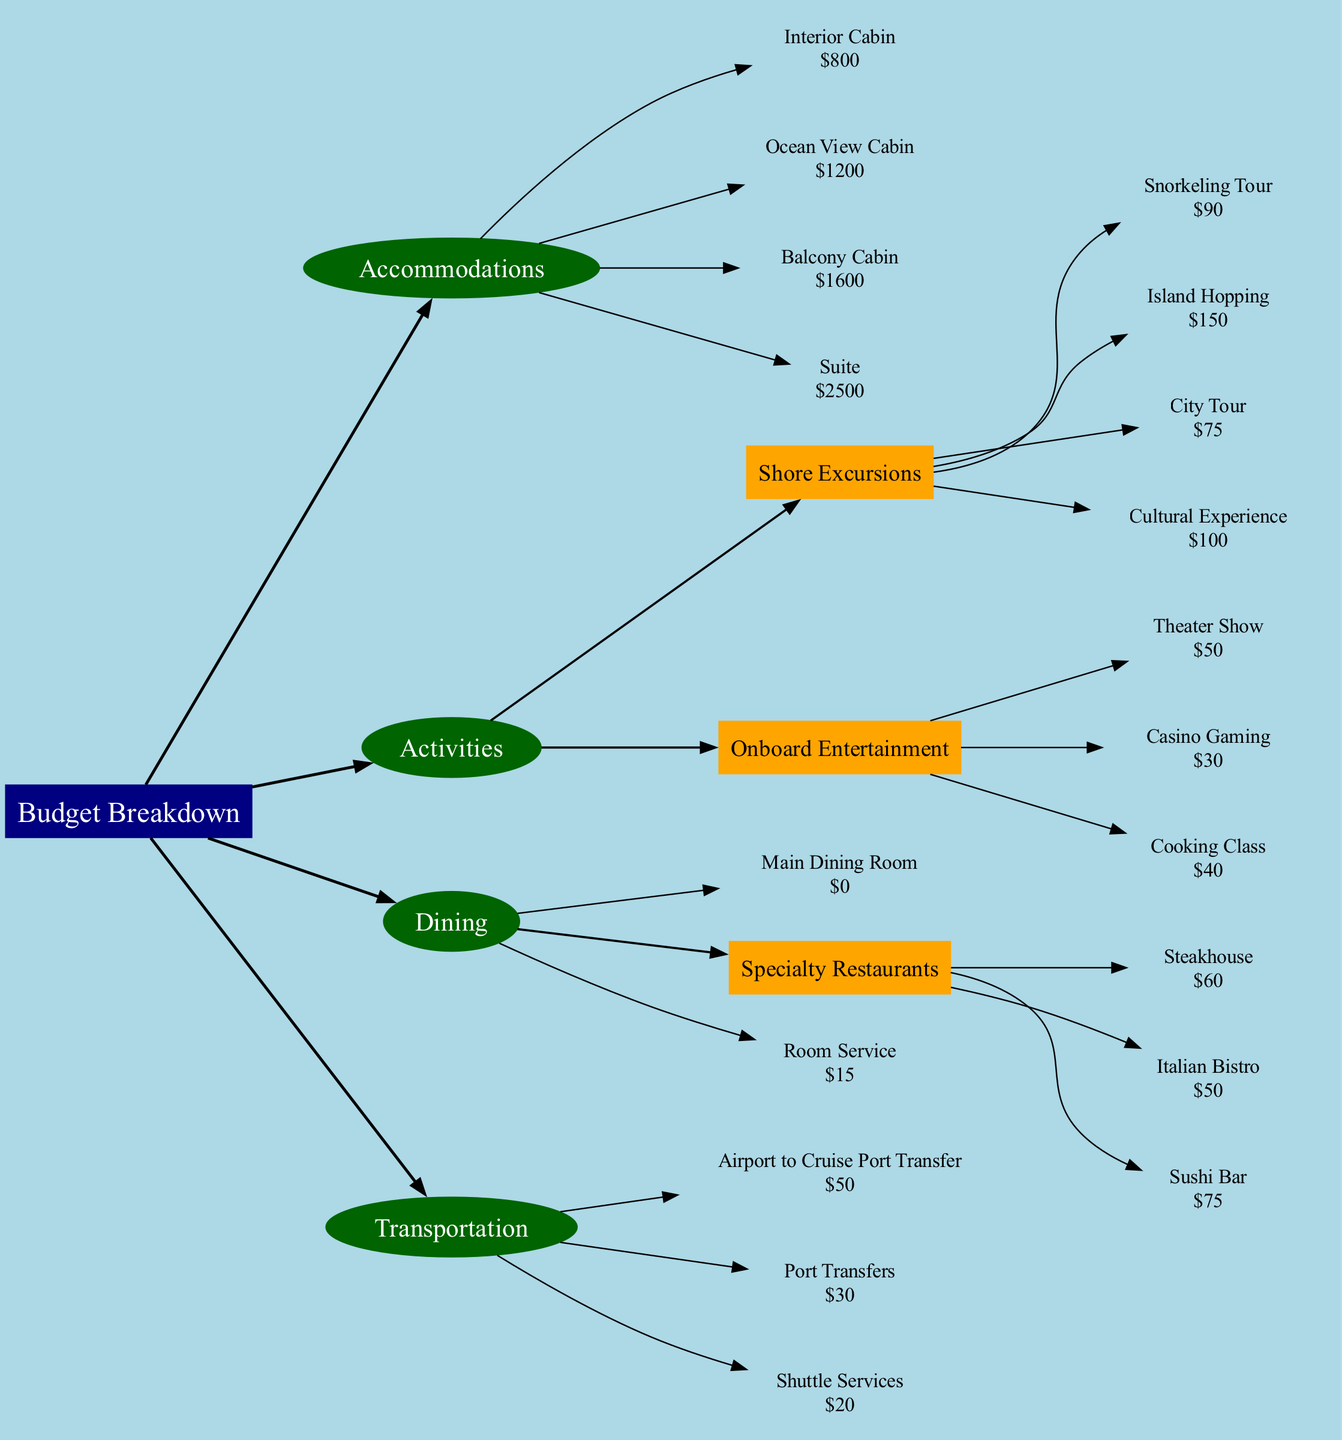What is the cost of a Balcony Cabin? The diagram presents the information under the Accommodations category. Specifically, the Balcony Cabin is listed as costing $1600.
Answer: $1600 How much does a Snorkeling Tour cost? The Snorkeling Tour is found in the Activities section, specifically within Shore Excursions, and it is priced at $90.
Answer: $90 What is the total cost of dining at the Specialty Restaurants? There are three Specialty Restaurants: Steakhouse costing $60, Italian Bistro costing $50, and Sushi Bar costing $75. The total is calculated as 60 + 50 + 75 = $185.
Answer: $185 Which activity has the highest cost? The activities are categorized under the Activities section. The highest cost belongs to Island Hopping at $150, which is greater than any other listed activity.
Answer: Island Hopping What is the total number of nodes in the diagram? The nodes include the main node (Budget Breakdown), four main categories (Accommodations, Activities, Dining, Transportation), their respective subcategories, and individual activities or dining options. In total, there are 15 nodes counted in the diagram.
Answer: 15 How many activities are listed under Onboard Entertainment? Under the Activities section, there are three distinct activities listed within Onboard Entertainment: Theater Show, Casino Gaming, and Cooking Class. This makes the total count of activities in this subcategory equal to 3.
Answer: 3 What is the total cost of transportation? The Transportation section lists three items: Airport to Cruise Port Transfer for $50, Port Transfers for $30, and Shuttle Services for $20. The total is calculated as 50 + 30 + 20 = $100.
Answer: $100 Which type of cabin costs the least? Under Accommodations, the different cabin types are Interior Cabin ($800), Ocean View Cabin ($1200), Balcony Cabin ($1600), and Suite ($2500). The Interior Cabin, being the least expensive at $800, is the answer.
Answer: Interior Cabin Which dining option has a price of $15? The Room Service option under the Dining category is priced at $15, making it the answer to this question.
Answer: Room Service 